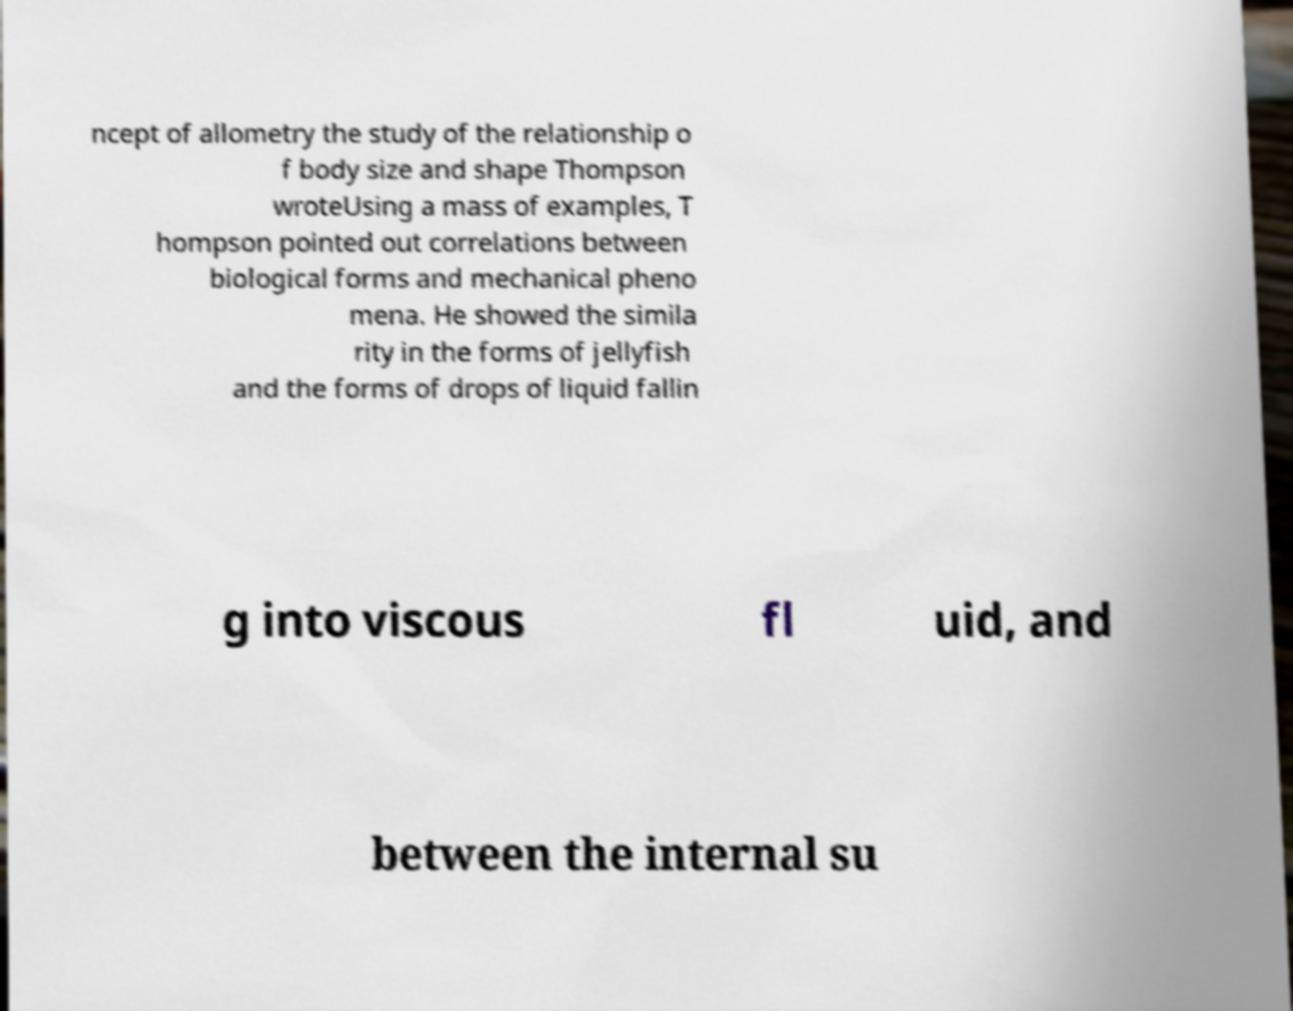For documentation purposes, I need the text within this image transcribed. Could you provide that? ncept of allometry the study of the relationship o f body size and shape Thompson wroteUsing a mass of examples, T hompson pointed out correlations between biological forms and mechanical pheno mena. He showed the simila rity in the forms of jellyfish and the forms of drops of liquid fallin g into viscous fl uid, and between the internal su 